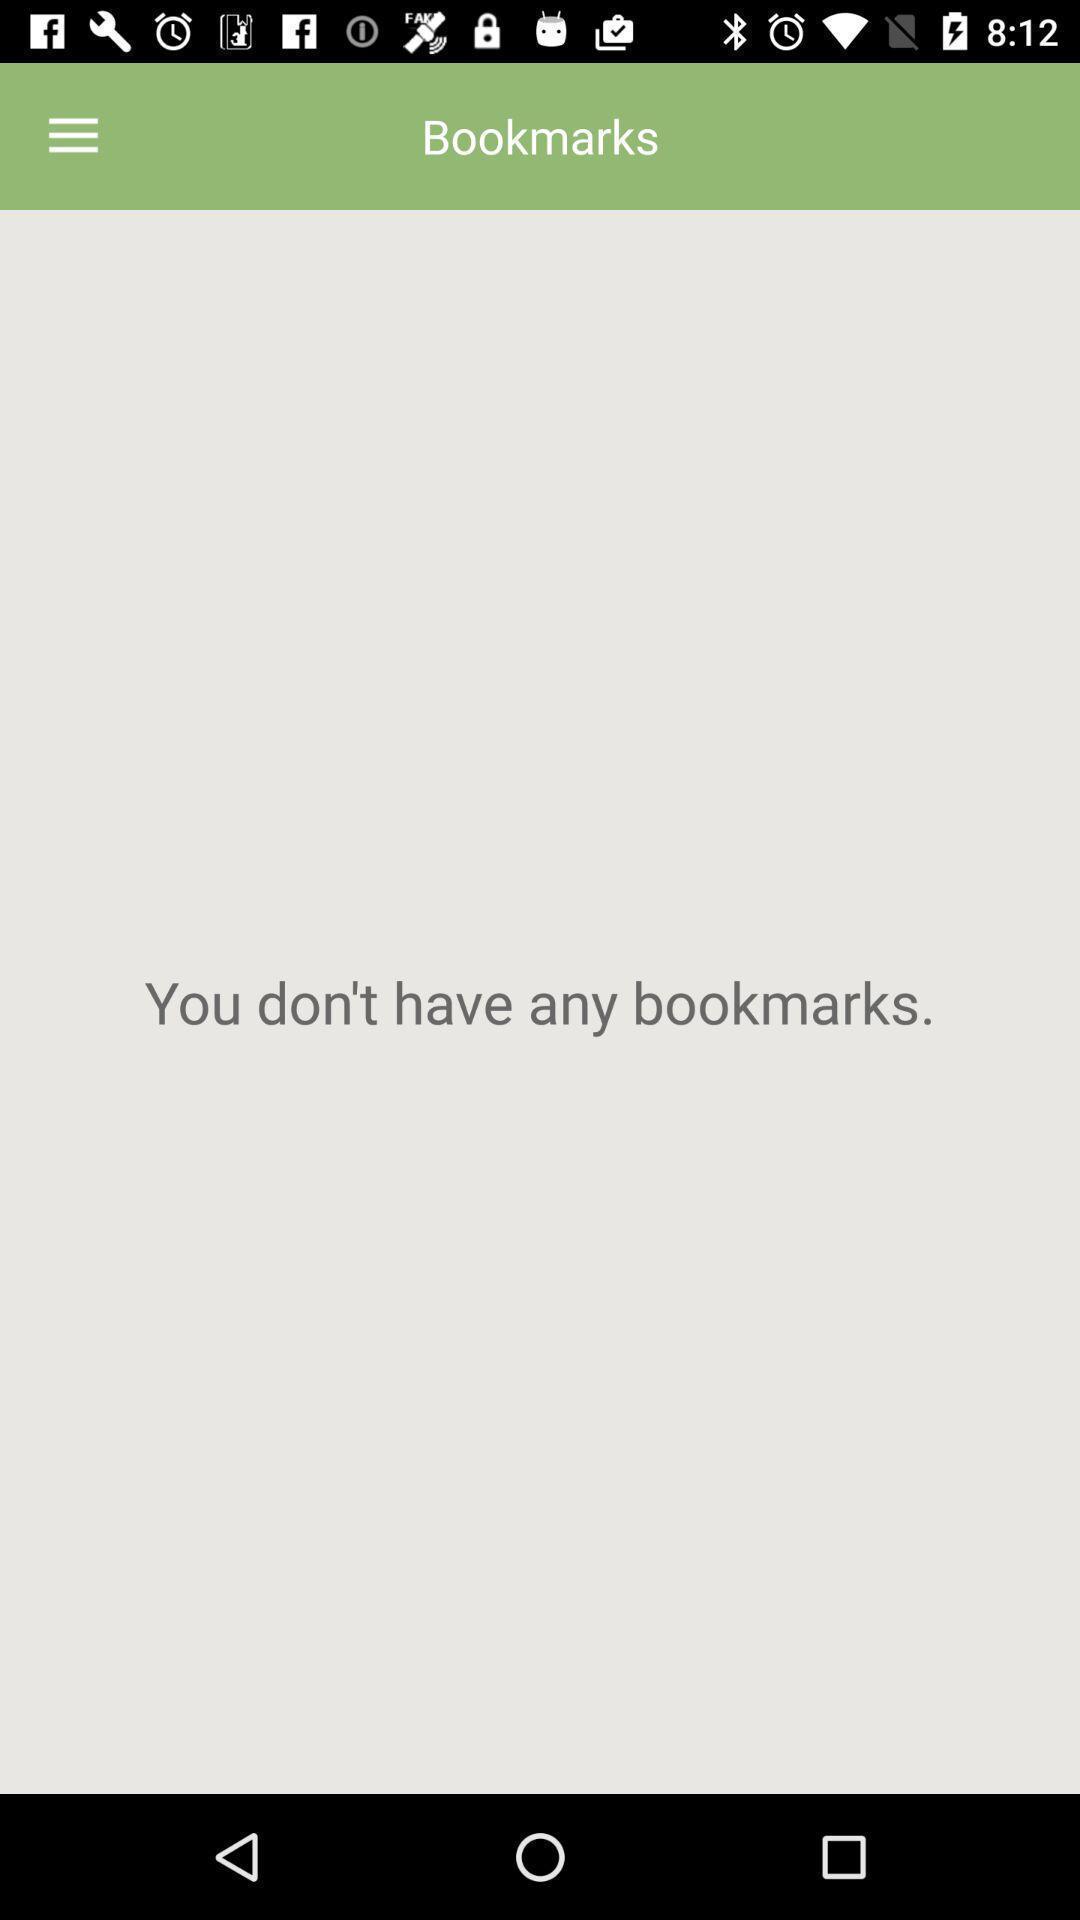Give me a narrative description of this picture. Screen displaying results of saved messages. 